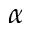<formula> <loc_0><loc_0><loc_500><loc_500>\alpha</formula> 